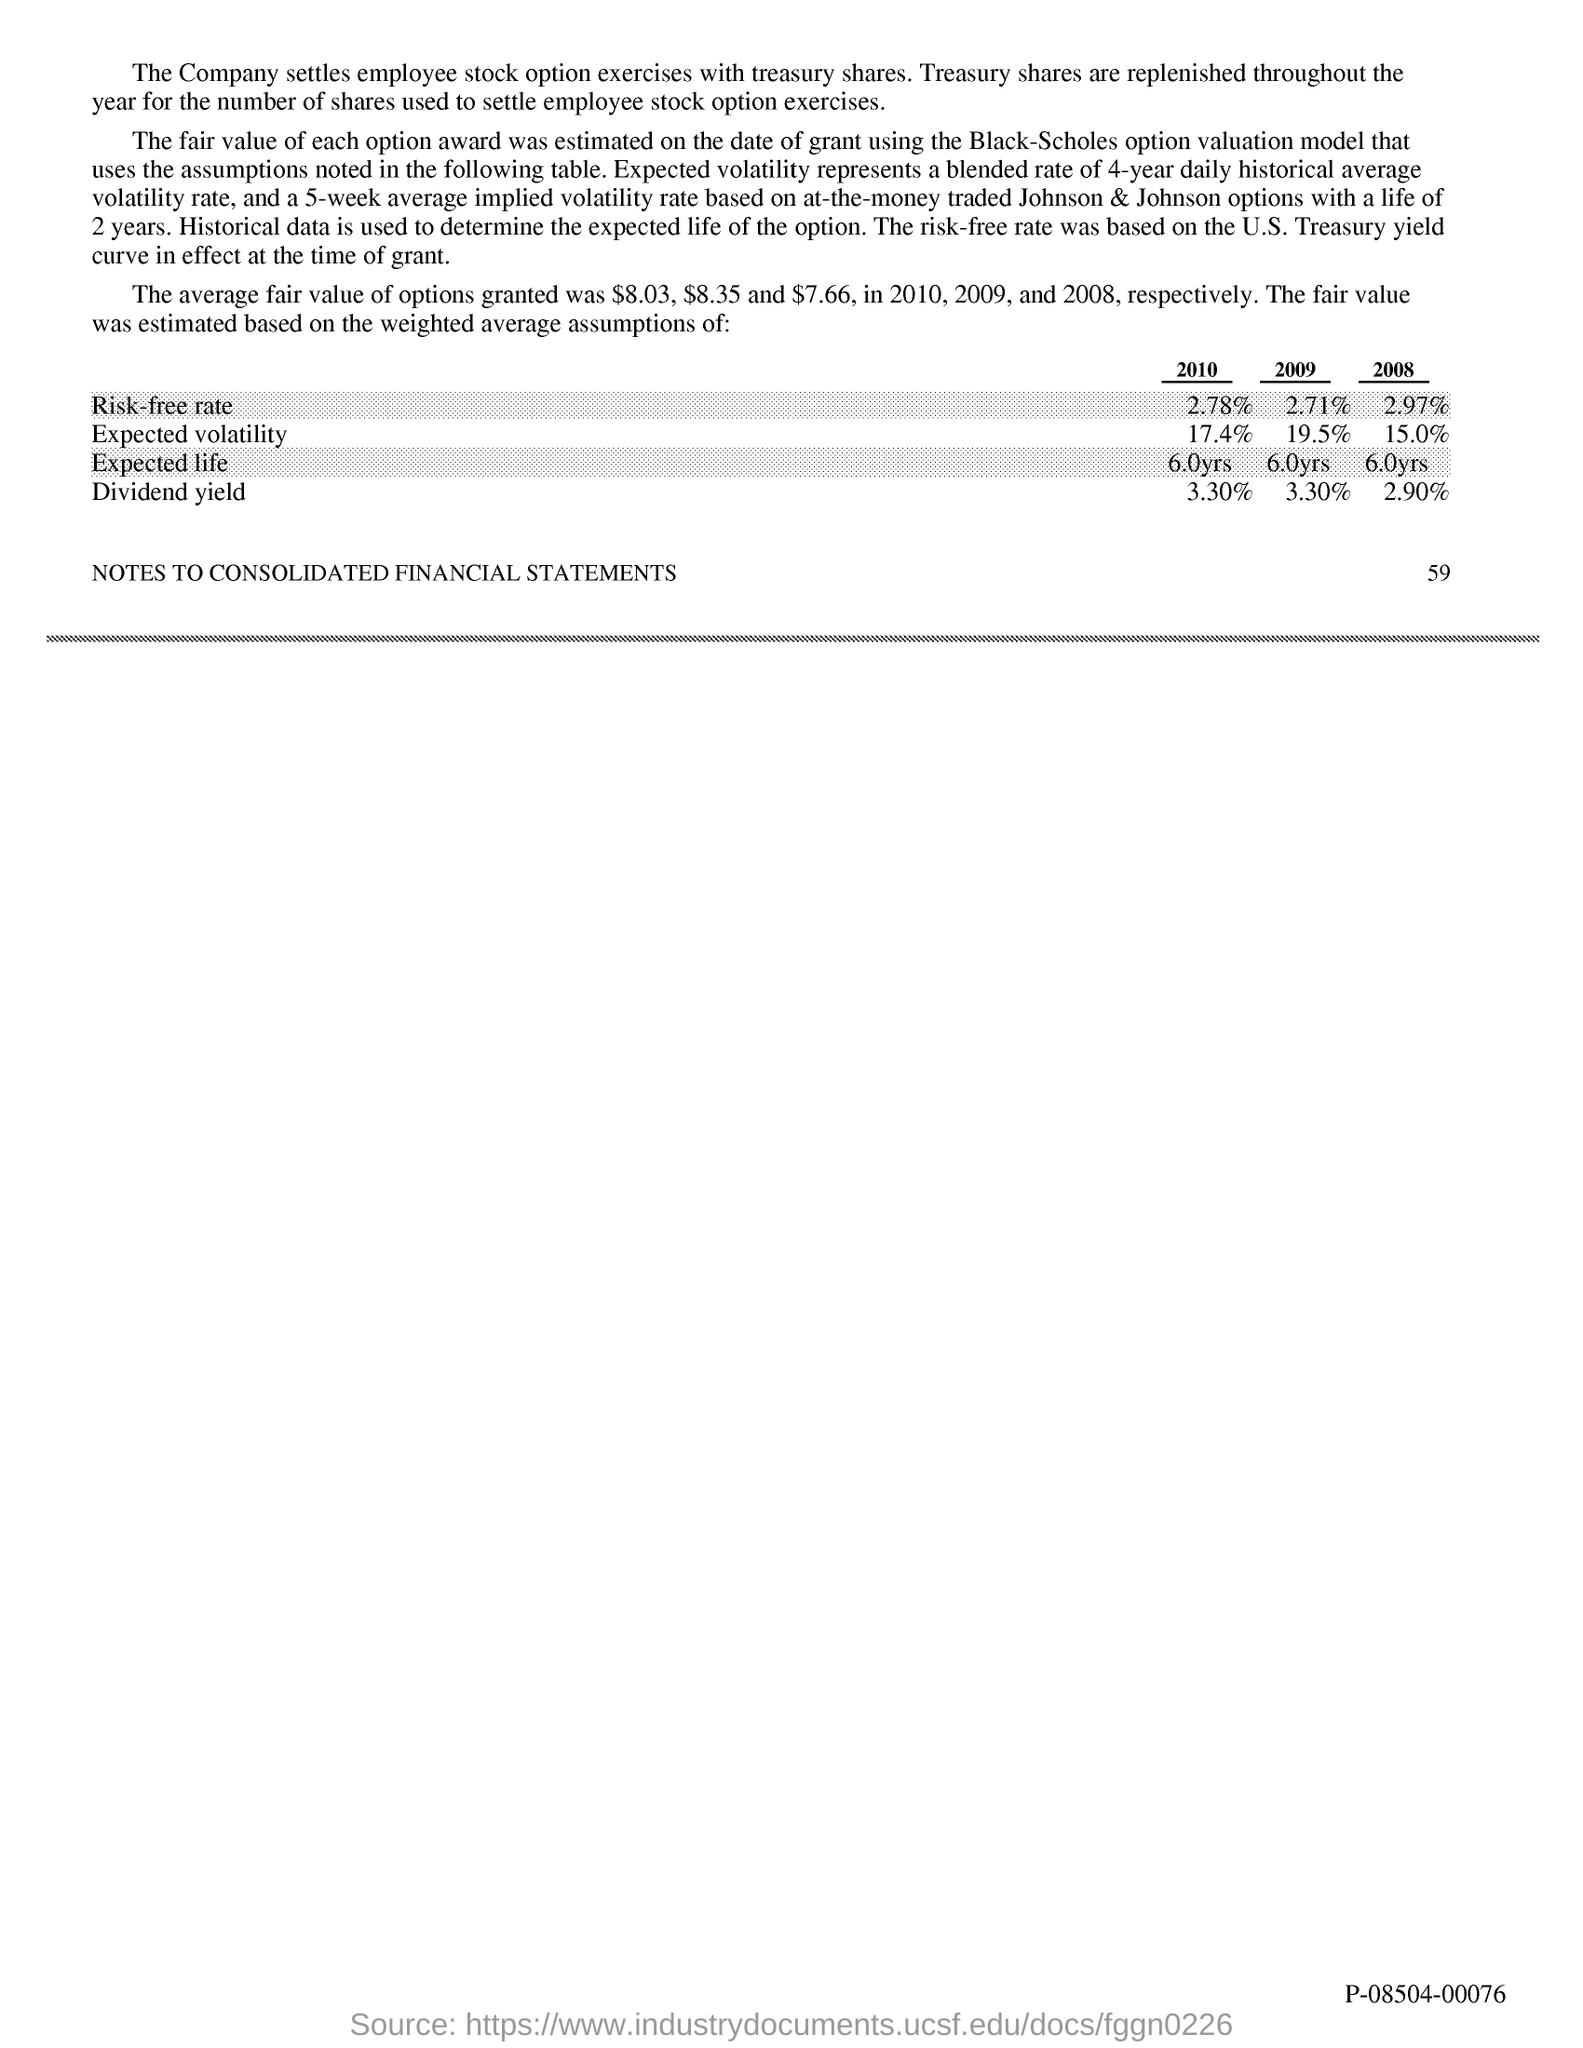Indicate a few pertinent items in this graphic. The risk-free rate for 2009 was 2.71%. The expected volatility for 2010 was 17.4%. The expected lifespan for individuals born in 2009 is approximately 6.0 years. The expected volatility for 2008 was 15.0%. The expected lifespan for a vehicle with a model year of 2008 is approximately 6 years. 